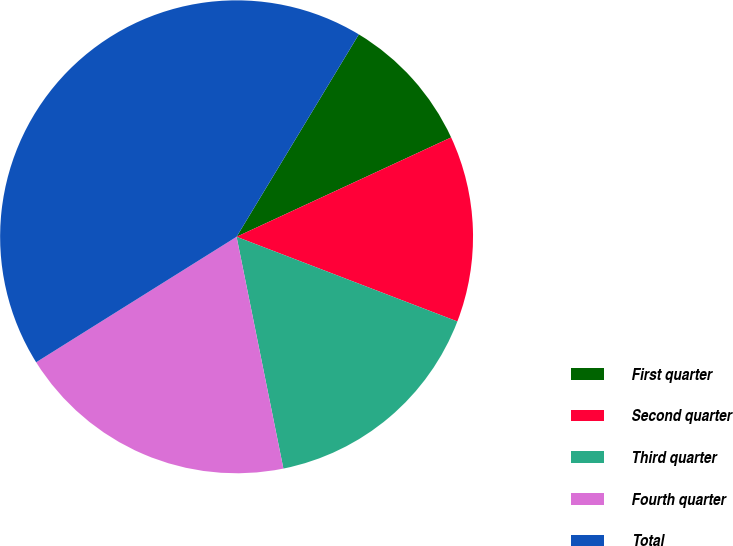<chart> <loc_0><loc_0><loc_500><loc_500><pie_chart><fcel>First quarter<fcel>Second quarter<fcel>Third quarter<fcel>Fourth quarter<fcel>Total<nl><fcel>9.45%<fcel>12.73%<fcel>16.0%<fcel>19.27%<fcel>42.55%<nl></chart> 